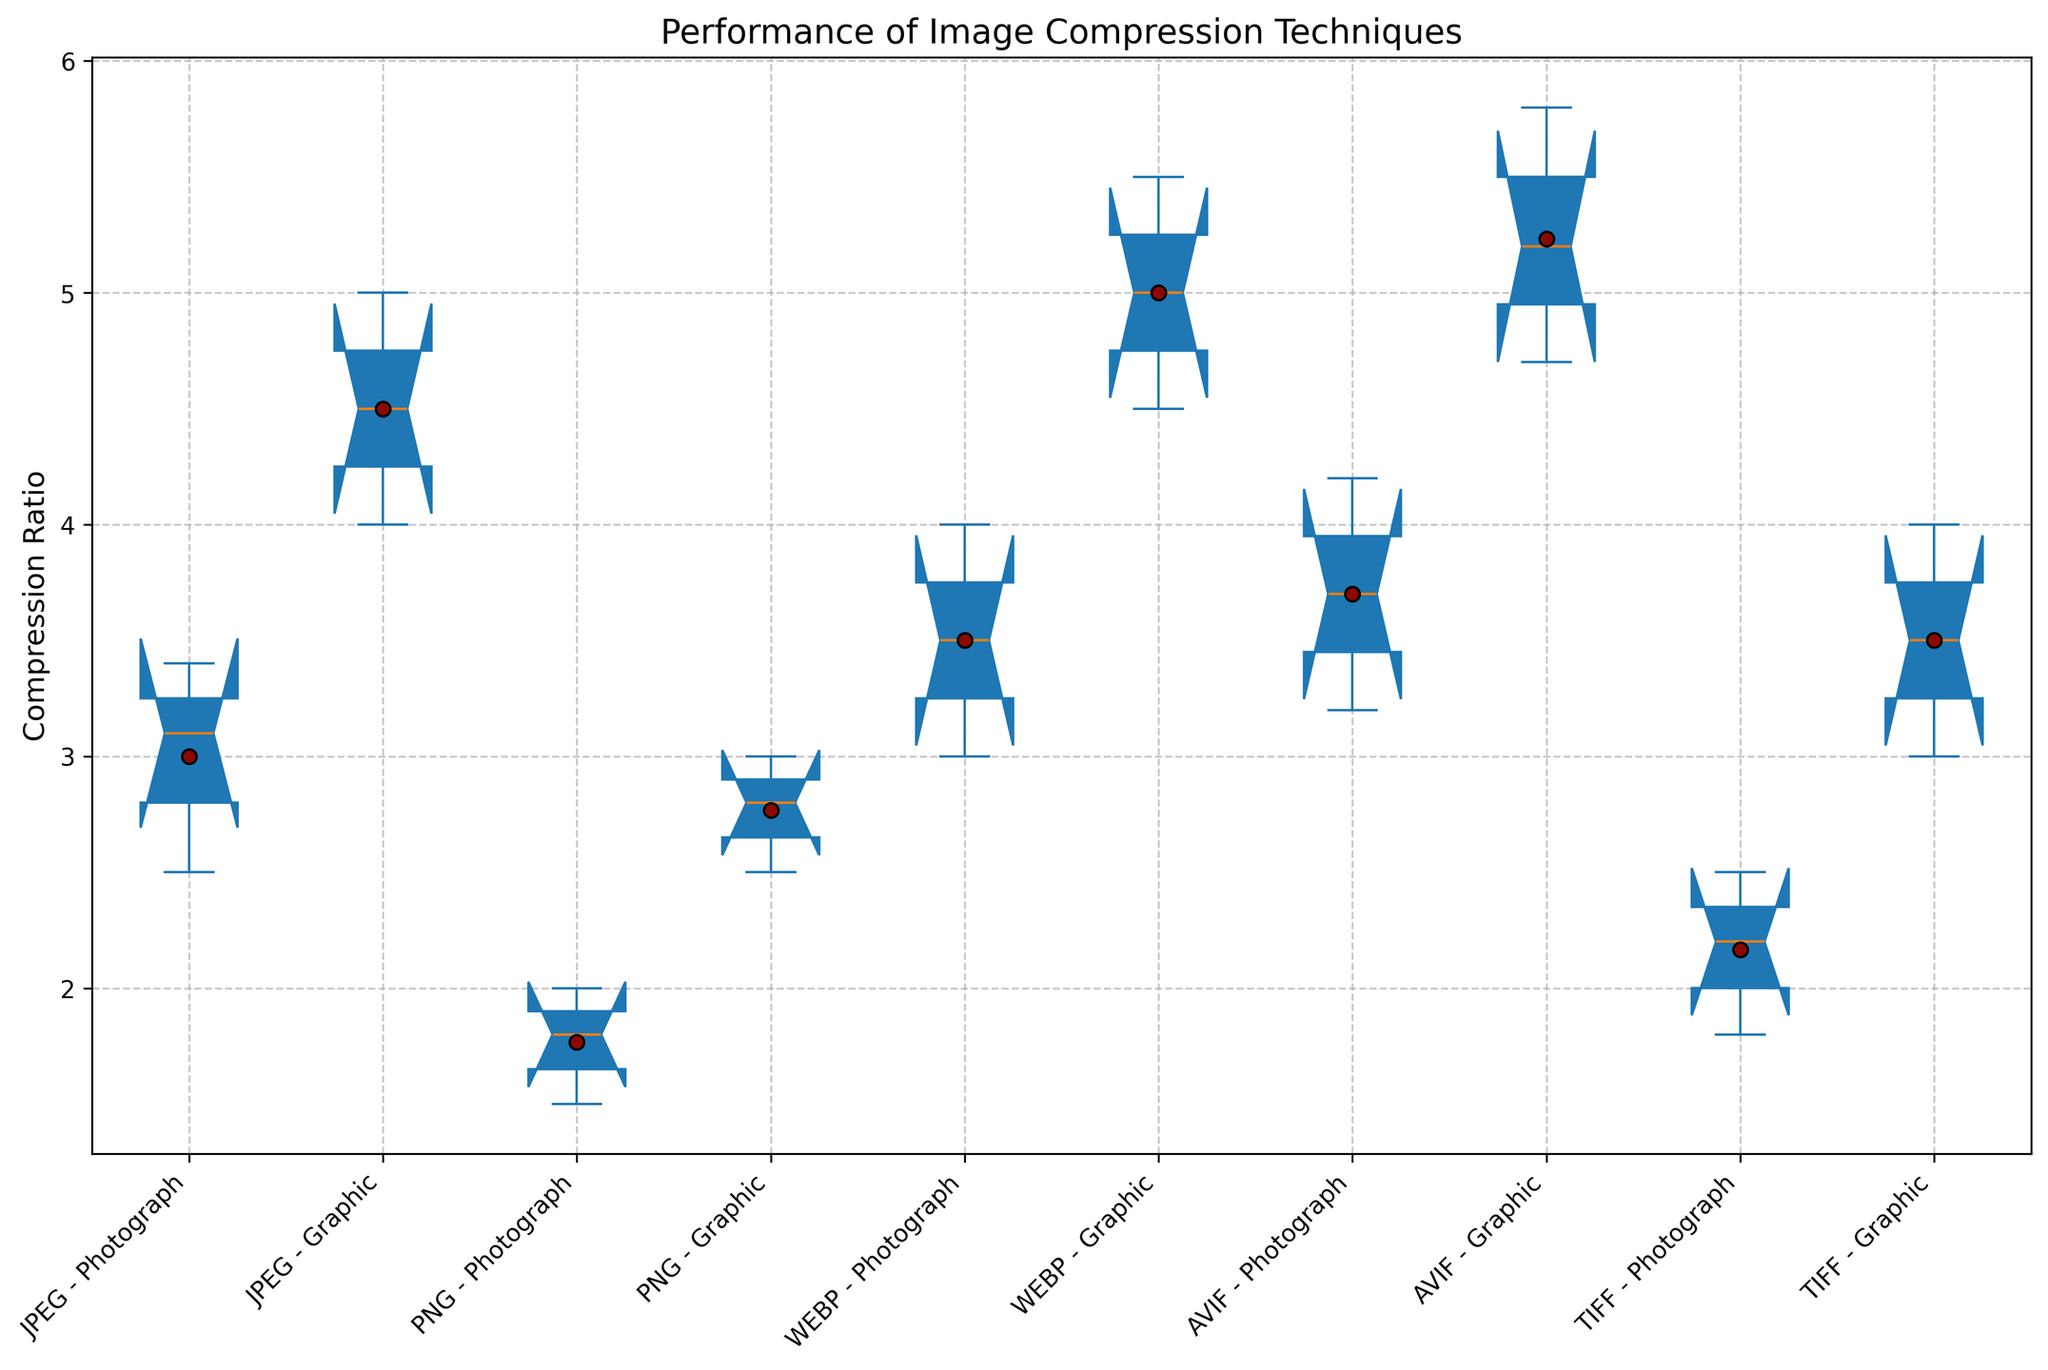What's the median compression ratio for JPEG on graphical images? To find the median compression ratio for JPEG on graphical images, look at the box representing JPEG for graphical images. The median is the line inside the box.
Answer: 4.5 How does the average compression ratio of JPEG on photographs compare to that of WEBP on photographs? Calculate the average for both: JPEG on photographs (2.5 + 3.1 + 3.4) / 3 = 3.0, WEBP on photographs (3.0 + 3.5 + 4.0) / 3 = 3.5. Compare the two averages.
Answer: 3.0 vs 3.5; WEBP is higher Which technique has the highest mean compression ratio for graphical images? Identify the mean from the markers inside the boxes for each technique on graphical images. The mean marker is indicated by a different color (typically green).
Answer: AVIF Is the interquartile range (IQR) of compression ratios for PNG on graphical images wider or narrower than that of TIFF on graphical images? Compare the height of the boxes (which represent the IQR) for PNG and TIFF on graphical images. The IQR is the range between the bottom and top of the box.
Answer: Narrower Which technique shows the most consistent compression performance across different image sizes for photographs (small, medium, large)? Consistency can be inferred from the spread of the data points (whiskers’ length). The technique with the smallest range (small whiskers) is the most consistent.
Answer: TIFF What is the minimum compression ratio achieved by AVIF on photographs? Locate the minimum value represented by the end of the lower whisker for AVIF on photographs.
Answer: 3.2 By how much does the median compression ratio for WEBP graphical images surpass that of PNG graphical images? The median ratio for WEBP graphical images is the line inside the WEBP box, which is at 5.0. For PNG, the median is at 2.8. The difference is 5.0 - 2.8.
Answer: 2.2 Which combination of technique and image type has the highest variability in compression ratios? Variability is reflected by the length of the whiskers. Look at each combination and find the one with the longest whiskers.
Answer: AVIF on graphical images What is the upper whisker limit for JPEG on large graphical images? The upper whisker represents the highest data point excluding outliers. For JPEG on large graphical images, observe the tip of the upper whisker.
Answer: 5.0 Which technique has the lowest median compression ratio across all types and sizes of images? Compare the median values (lines inside the boxes) for each technique across all image types.
Answer: PNG 